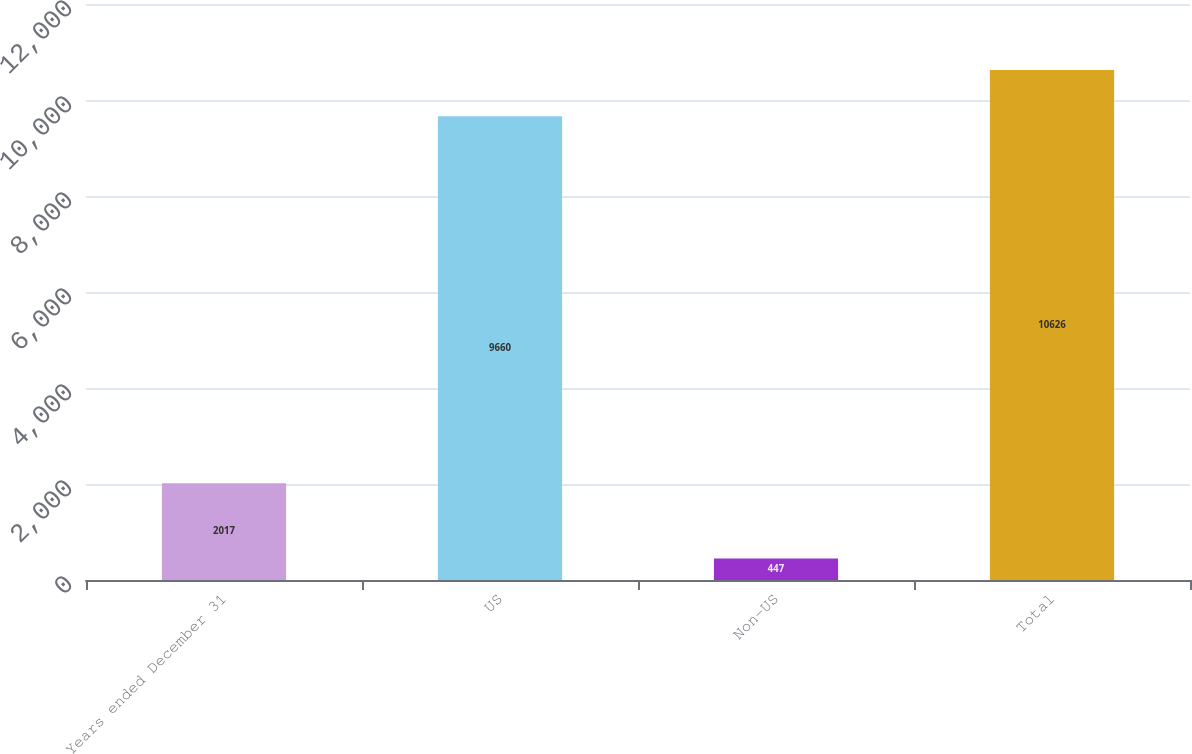Convert chart. <chart><loc_0><loc_0><loc_500><loc_500><bar_chart><fcel>Years ended December 31<fcel>US<fcel>Non-US<fcel>Total<nl><fcel>2017<fcel>9660<fcel>447<fcel>10626<nl></chart> 